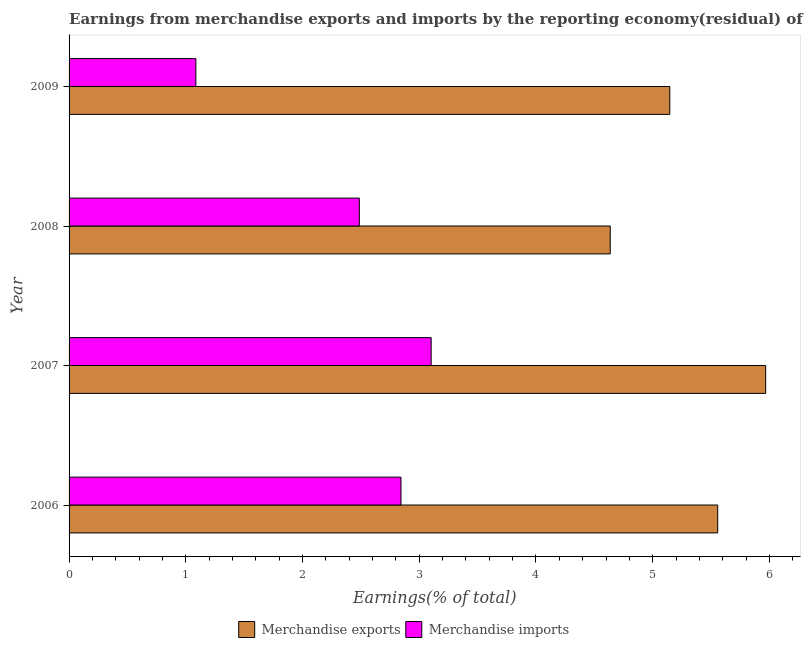How many groups of bars are there?
Your answer should be very brief. 4. Are the number of bars per tick equal to the number of legend labels?
Your answer should be very brief. Yes. Are the number of bars on each tick of the Y-axis equal?
Make the answer very short. Yes. How many bars are there on the 4th tick from the top?
Ensure brevity in your answer.  2. How many bars are there on the 4th tick from the bottom?
Your answer should be very brief. 2. What is the earnings from merchandise exports in 2006?
Make the answer very short. 5.56. Across all years, what is the maximum earnings from merchandise imports?
Your answer should be compact. 3.1. Across all years, what is the minimum earnings from merchandise exports?
Make the answer very short. 4.64. In which year was the earnings from merchandise exports maximum?
Offer a very short reply. 2007. What is the total earnings from merchandise imports in the graph?
Your response must be concise. 9.52. What is the difference between the earnings from merchandise imports in 2007 and that in 2008?
Provide a short and direct response. 0.61. What is the difference between the earnings from merchandise exports in 2008 and the earnings from merchandise imports in 2007?
Offer a terse response. 1.53. What is the average earnings from merchandise imports per year?
Make the answer very short. 2.38. In the year 2008, what is the difference between the earnings from merchandise imports and earnings from merchandise exports?
Give a very brief answer. -2.15. Is the earnings from merchandise exports in 2008 less than that in 2009?
Give a very brief answer. Yes. What is the difference between the highest and the second highest earnings from merchandise imports?
Provide a succinct answer. 0.26. What is the difference between the highest and the lowest earnings from merchandise exports?
Keep it short and to the point. 1.33. In how many years, is the earnings from merchandise exports greater than the average earnings from merchandise exports taken over all years?
Your response must be concise. 2. Is the sum of the earnings from merchandise exports in 2007 and 2008 greater than the maximum earnings from merchandise imports across all years?
Your response must be concise. Yes. What does the 2nd bar from the top in 2008 represents?
Offer a terse response. Merchandise exports. How many years are there in the graph?
Your answer should be compact. 4. What is the difference between two consecutive major ticks on the X-axis?
Make the answer very short. 1. Are the values on the major ticks of X-axis written in scientific E-notation?
Keep it short and to the point. No. How are the legend labels stacked?
Keep it short and to the point. Horizontal. What is the title of the graph?
Offer a very short reply. Earnings from merchandise exports and imports by the reporting economy(residual) of Middle East & North Africa (developing only). Does "Malaria" appear as one of the legend labels in the graph?
Offer a terse response. No. What is the label or title of the X-axis?
Offer a very short reply. Earnings(% of total). What is the Earnings(% of total) in Merchandise exports in 2006?
Provide a succinct answer. 5.56. What is the Earnings(% of total) in Merchandise imports in 2006?
Offer a very short reply. 2.84. What is the Earnings(% of total) of Merchandise exports in 2007?
Your response must be concise. 5.97. What is the Earnings(% of total) of Merchandise imports in 2007?
Your answer should be very brief. 3.1. What is the Earnings(% of total) in Merchandise exports in 2008?
Offer a very short reply. 4.64. What is the Earnings(% of total) of Merchandise imports in 2008?
Offer a terse response. 2.49. What is the Earnings(% of total) in Merchandise exports in 2009?
Offer a very short reply. 5.15. What is the Earnings(% of total) of Merchandise imports in 2009?
Make the answer very short. 1.09. Across all years, what is the maximum Earnings(% of total) in Merchandise exports?
Ensure brevity in your answer.  5.97. Across all years, what is the maximum Earnings(% of total) of Merchandise imports?
Provide a succinct answer. 3.1. Across all years, what is the minimum Earnings(% of total) in Merchandise exports?
Offer a terse response. 4.64. Across all years, what is the minimum Earnings(% of total) in Merchandise imports?
Offer a terse response. 1.09. What is the total Earnings(% of total) of Merchandise exports in the graph?
Your answer should be compact. 21.31. What is the total Earnings(% of total) of Merchandise imports in the graph?
Ensure brevity in your answer.  9.52. What is the difference between the Earnings(% of total) of Merchandise exports in 2006 and that in 2007?
Make the answer very short. -0.41. What is the difference between the Earnings(% of total) of Merchandise imports in 2006 and that in 2007?
Your answer should be very brief. -0.26. What is the difference between the Earnings(% of total) in Merchandise exports in 2006 and that in 2008?
Make the answer very short. 0.92. What is the difference between the Earnings(% of total) in Merchandise imports in 2006 and that in 2008?
Make the answer very short. 0.36. What is the difference between the Earnings(% of total) of Merchandise exports in 2006 and that in 2009?
Offer a terse response. 0.41. What is the difference between the Earnings(% of total) of Merchandise imports in 2006 and that in 2009?
Offer a very short reply. 1.76. What is the difference between the Earnings(% of total) of Merchandise exports in 2007 and that in 2008?
Keep it short and to the point. 1.33. What is the difference between the Earnings(% of total) in Merchandise imports in 2007 and that in 2008?
Offer a very short reply. 0.62. What is the difference between the Earnings(% of total) in Merchandise exports in 2007 and that in 2009?
Provide a short and direct response. 0.82. What is the difference between the Earnings(% of total) in Merchandise imports in 2007 and that in 2009?
Offer a very short reply. 2.02. What is the difference between the Earnings(% of total) in Merchandise exports in 2008 and that in 2009?
Give a very brief answer. -0.51. What is the difference between the Earnings(% of total) in Merchandise imports in 2008 and that in 2009?
Give a very brief answer. 1.4. What is the difference between the Earnings(% of total) of Merchandise exports in 2006 and the Earnings(% of total) of Merchandise imports in 2007?
Provide a succinct answer. 2.45. What is the difference between the Earnings(% of total) of Merchandise exports in 2006 and the Earnings(% of total) of Merchandise imports in 2008?
Give a very brief answer. 3.07. What is the difference between the Earnings(% of total) of Merchandise exports in 2006 and the Earnings(% of total) of Merchandise imports in 2009?
Ensure brevity in your answer.  4.47. What is the difference between the Earnings(% of total) of Merchandise exports in 2007 and the Earnings(% of total) of Merchandise imports in 2008?
Make the answer very short. 3.48. What is the difference between the Earnings(% of total) in Merchandise exports in 2007 and the Earnings(% of total) in Merchandise imports in 2009?
Your answer should be compact. 4.88. What is the difference between the Earnings(% of total) of Merchandise exports in 2008 and the Earnings(% of total) of Merchandise imports in 2009?
Your answer should be compact. 3.55. What is the average Earnings(% of total) in Merchandise exports per year?
Your answer should be very brief. 5.33. What is the average Earnings(% of total) in Merchandise imports per year?
Keep it short and to the point. 2.38. In the year 2006, what is the difference between the Earnings(% of total) in Merchandise exports and Earnings(% of total) in Merchandise imports?
Keep it short and to the point. 2.71. In the year 2007, what is the difference between the Earnings(% of total) in Merchandise exports and Earnings(% of total) in Merchandise imports?
Ensure brevity in your answer.  2.87. In the year 2008, what is the difference between the Earnings(% of total) in Merchandise exports and Earnings(% of total) in Merchandise imports?
Make the answer very short. 2.15. In the year 2009, what is the difference between the Earnings(% of total) of Merchandise exports and Earnings(% of total) of Merchandise imports?
Offer a terse response. 4.06. What is the ratio of the Earnings(% of total) in Merchandise exports in 2006 to that in 2007?
Offer a very short reply. 0.93. What is the ratio of the Earnings(% of total) of Merchandise imports in 2006 to that in 2007?
Ensure brevity in your answer.  0.92. What is the ratio of the Earnings(% of total) in Merchandise exports in 2006 to that in 2008?
Your response must be concise. 1.2. What is the ratio of the Earnings(% of total) in Merchandise imports in 2006 to that in 2008?
Offer a terse response. 1.14. What is the ratio of the Earnings(% of total) in Merchandise exports in 2006 to that in 2009?
Make the answer very short. 1.08. What is the ratio of the Earnings(% of total) of Merchandise imports in 2006 to that in 2009?
Your answer should be very brief. 2.62. What is the ratio of the Earnings(% of total) in Merchandise exports in 2007 to that in 2008?
Provide a succinct answer. 1.29. What is the ratio of the Earnings(% of total) of Merchandise imports in 2007 to that in 2008?
Provide a succinct answer. 1.25. What is the ratio of the Earnings(% of total) of Merchandise exports in 2007 to that in 2009?
Offer a very short reply. 1.16. What is the ratio of the Earnings(% of total) in Merchandise imports in 2007 to that in 2009?
Offer a terse response. 2.86. What is the ratio of the Earnings(% of total) in Merchandise exports in 2008 to that in 2009?
Your answer should be very brief. 0.9. What is the ratio of the Earnings(% of total) of Merchandise imports in 2008 to that in 2009?
Make the answer very short. 2.29. What is the difference between the highest and the second highest Earnings(% of total) in Merchandise exports?
Offer a very short reply. 0.41. What is the difference between the highest and the second highest Earnings(% of total) in Merchandise imports?
Offer a terse response. 0.26. What is the difference between the highest and the lowest Earnings(% of total) in Merchandise exports?
Make the answer very short. 1.33. What is the difference between the highest and the lowest Earnings(% of total) in Merchandise imports?
Keep it short and to the point. 2.02. 